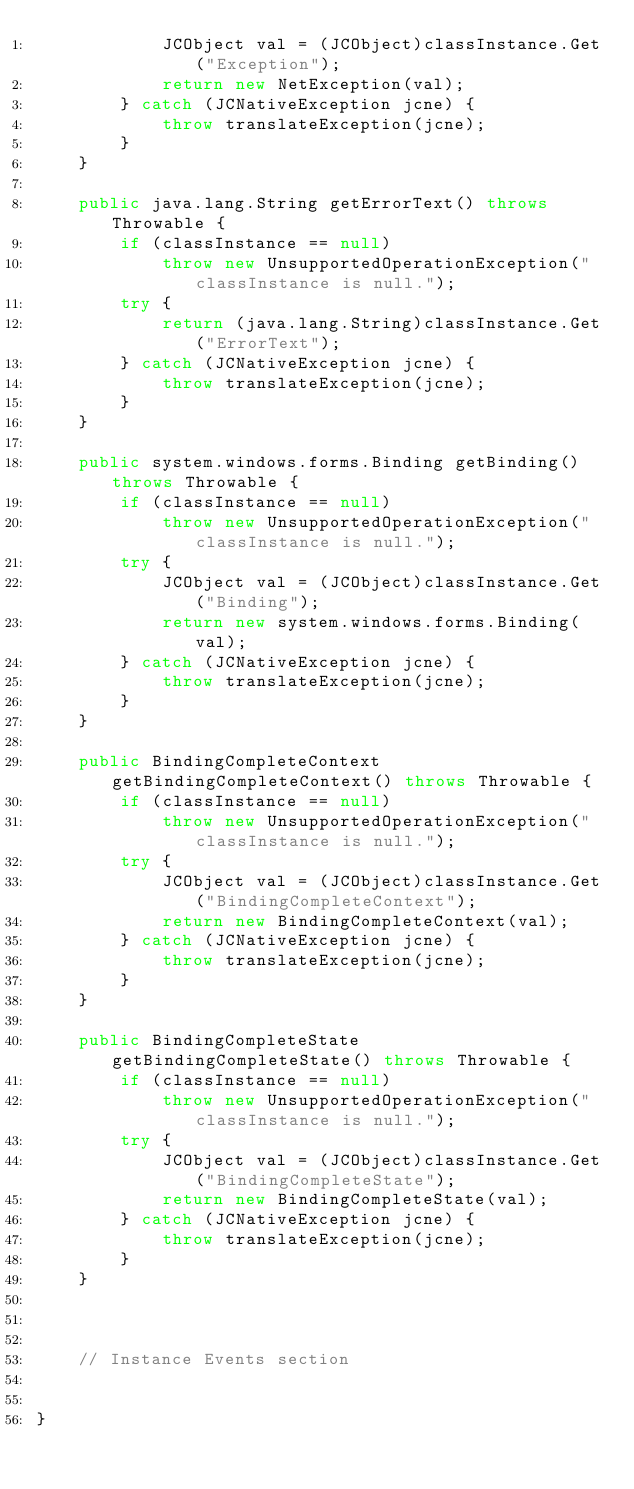<code> <loc_0><loc_0><loc_500><loc_500><_Java_>            JCObject val = (JCObject)classInstance.Get("Exception");
            return new NetException(val);
        } catch (JCNativeException jcne) {
            throw translateException(jcne);
        }
    }

    public java.lang.String getErrorText() throws Throwable {
        if (classInstance == null)
            throw new UnsupportedOperationException("classInstance is null.");
        try {
            return (java.lang.String)classInstance.Get("ErrorText");
        } catch (JCNativeException jcne) {
            throw translateException(jcne);
        }
    }

    public system.windows.forms.Binding getBinding() throws Throwable {
        if (classInstance == null)
            throw new UnsupportedOperationException("classInstance is null.");
        try {
            JCObject val = (JCObject)classInstance.Get("Binding");
            return new system.windows.forms.Binding(val);
        } catch (JCNativeException jcne) {
            throw translateException(jcne);
        }
    }

    public BindingCompleteContext getBindingCompleteContext() throws Throwable {
        if (classInstance == null)
            throw new UnsupportedOperationException("classInstance is null.");
        try {
            JCObject val = (JCObject)classInstance.Get("BindingCompleteContext");
            return new BindingCompleteContext(val);
        } catch (JCNativeException jcne) {
            throw translateException(jcne);
        }
    }

    public BindingCompleteState getBindingCompleteState() throws Throwable {
        if (classInstance == null)
            throw new UnsupportedOperationException("classInstance is null.");
        try {
            JCObject val = (JCObject)classInstance.Get("BindingCompleteState");
            return new BindingCompleteState(val);
        } catch (JCNativeException jcne) {
            throw translateException(jcne);
        }
    }



    // Instance Events section
    

}</code> 